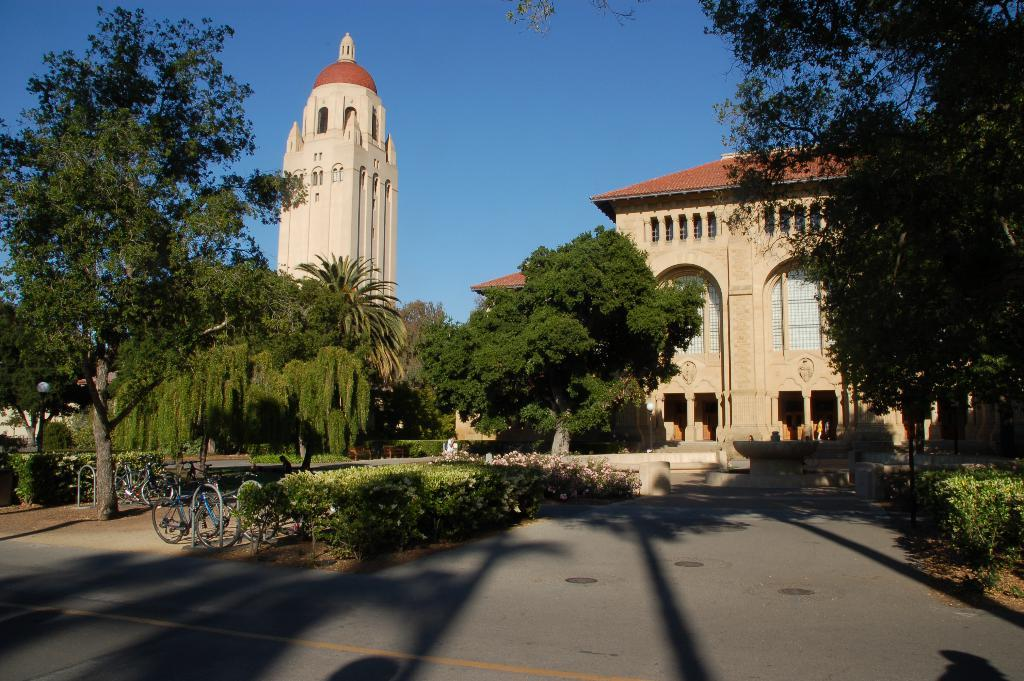What is in the foreground of the image? There is a road in the foreground of the image. What type of natural elements can be seen in the image? There are trees and plants in the image. What type of man-made structures are present in the image? There are buildings in the image. What mode of transportation can be seen in the image? There are bicycles in the image. What is visible at the top of the image? The sky is visible at the top of the image. How many babies are playing with cushions in the image? There are no babies or cushions present in the image. 